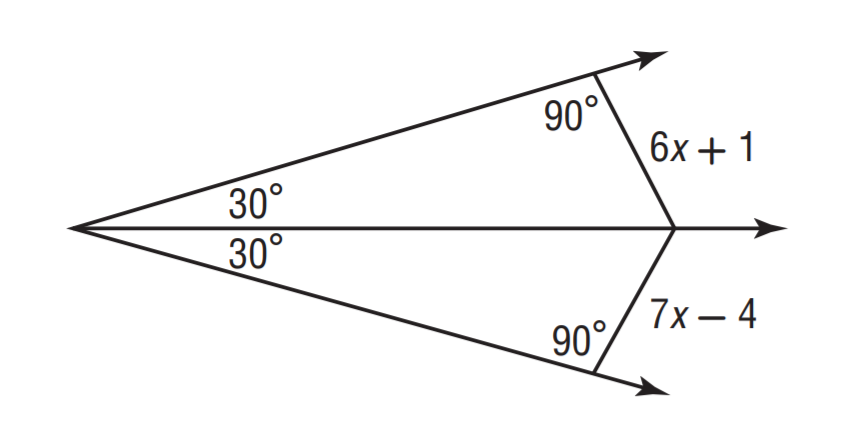Answer the mathemtical geometry problem and directly provide the correct option letter.
Question: Solve for x.
Choices: A: 3 B: 4 C: 5 D: 6 C 